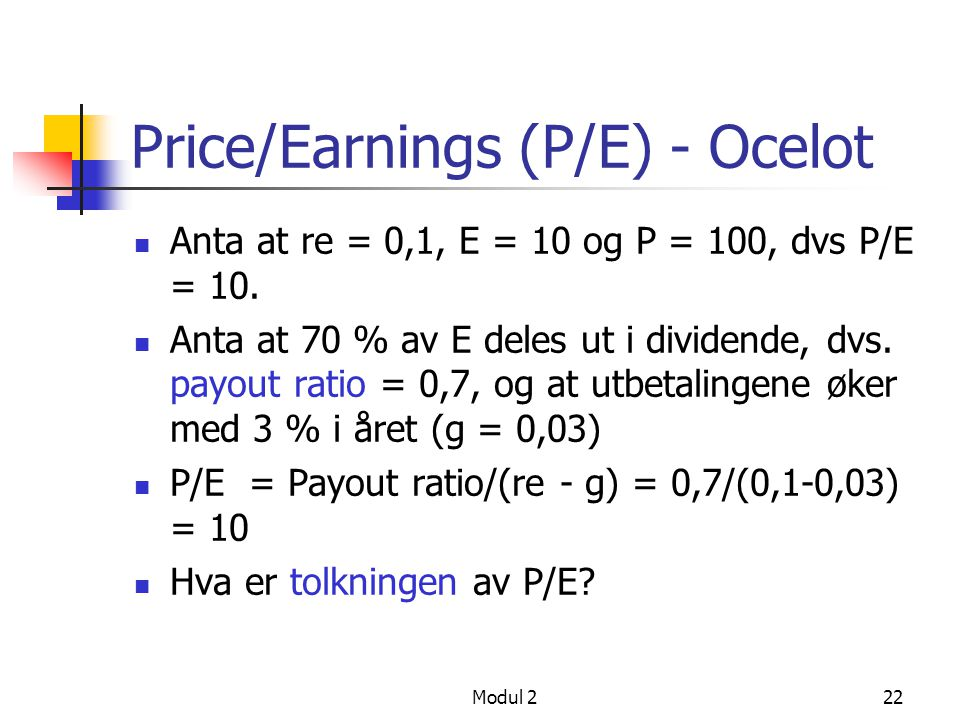How does the payout ratio affect the P/E ratio, and what does a high payout ratio indicate about a company's dividend policy? Based on the image, the P/E ratio is directly influenced by the payout ratio, with the formula for P/E being Payout ratio/(re - g). Therefore, when the payout ratio increases, it directly leads to a higher P/E ratio, given that the return on equity (re) and growth rate (g) remain constant. A high payout ratio implies that a company is distributing a substantial portion of its earnings to shareholders as dividends. This often indicates that the company is mature and might have fewer growth opportunities for reinvestment. As a result, it might be appealing to investors who prioritize regular, stable income from dividends. 